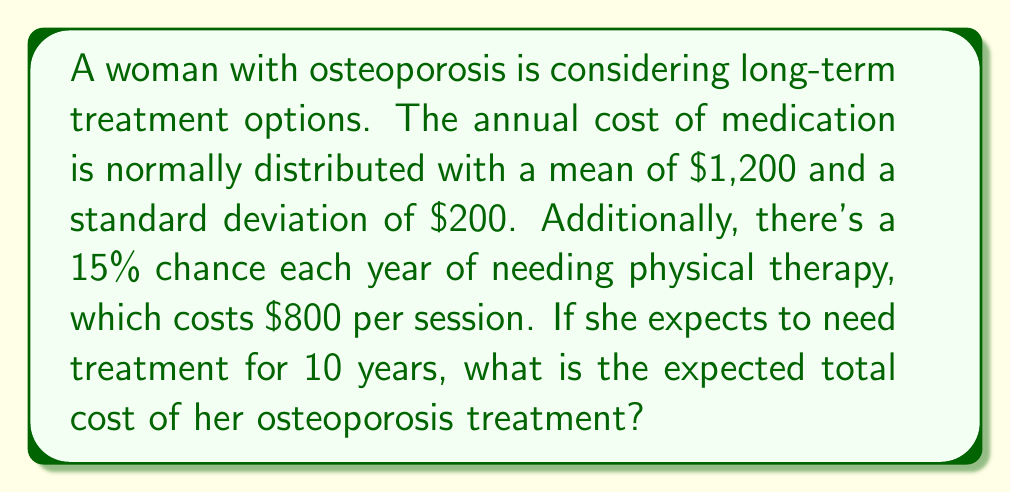Can you answer this question? Let's approach this problem step-by-step:

1) First, let's calculate the expected annual cost of medication:
   The medication cost follows a normal distribution with mean $\mu = 1200$ and standard deviation $\sigma = 200$.
   The expected value of a normal distribution is its mean, so the expected annual medication cost is $1200.

2) Now, let's calculate the expected annual cost of physical therapy:
   Probability of needing physical therapy = 15% = 0.15
   Cost of physical therapy = $800
   Expected annual cost of physical therapy = $0.15 \times 800 = $120

3) The total expected annual cost is the sum of these two components:
   $E[\text{Annual Cost}] = 1200 + 120 = $1320

4) The woman expects to need treatment for 10 years. Assuming the costs remain constant (in real terms) and are independent from year to year, we can multiply the annual cost by 10:

   $E[\text{Total Cost}] = 10 \times 1320 = $13,200

5) To formalize this in terms of a stochastic process, we can define:

   $X_t$ = Cost in year $t$
   $Y_t$ = Indicator variable for needing physical therapy in year $t$ (1 if needed, 0 if not)

   Then, $X_t = N(\mu, \sigma^2) + 800Y_t$ where $N(\mu, \sigma^2)$ is a normal random variable and $Y_t \sim \text{Bernoulli}(0.15)$

   The total cost over 10 years is $\sum_{t=1}^{10} X_t$

   By linearity of expectation:

   $$E[\sum_{t=1}^{10} X_t] = \sum_{t=1}^{10} E[X_t] = 10 \times E[X_t] = 10 \times 1320 = 13200$$

Therefore, the expected total cost of osteoporosis treatment over 10 years is $13,200.
Answer: $13,200 